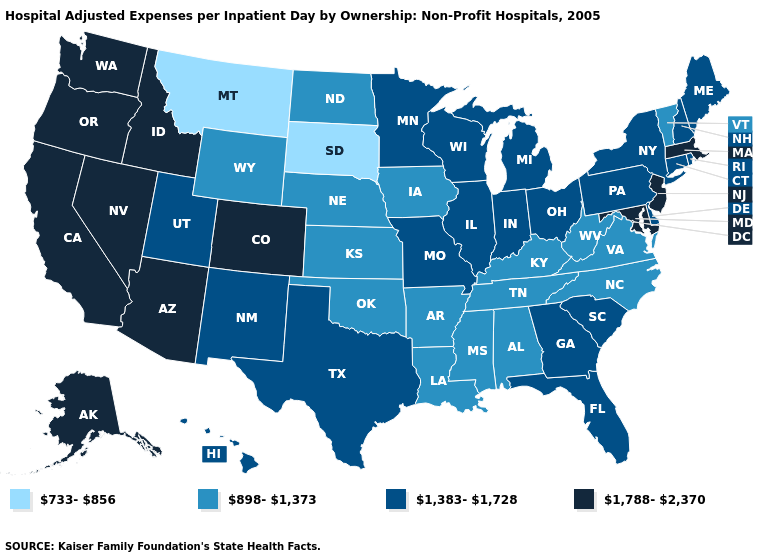What is the value of New Mexico?
Give a very brief answer. 1,383-1,728. What is the lowest value in states that border New Hampshire?
Keep it brief. 898-1,373. What is the value of Maryland?
Quick response, please. 1,788-2,370. Name the states that have a value in the range 1,788-2,370?
Write a very short answer. Alaska, Arizona, California, Colorado, Idaho, Maryland, Massachusetts, Nevada, New Jersey, Oregon, Washington. Does Delaware have a lower value than Texas?
Answer briefly. No. Among the states that border Kansas , which have the lowest value?
Concise answer only. Nebraska, Oklahoma. What is the lowest value in states that border Vermont?
Short answer required. 1,383-1,728. Among the states that border New Mexico , does Colorado have the highest value?
Write a very short answer. Yes. Name the states that have a value in the range 733-856?
Be succinct. Montana, South Dakota. Does Rhode Island have the same value as Illinois?
Keep it brief. Yes. What is the value of Idaho?
Keep it brief. 1,788-2,370. What is the lowest value in the MidWest?
Concise answer only. 733-856. Name the states that have a value in the range 733-856?
Be succinct. Montana, South Dakota. Name the states that have a value in the range 1,383-1,728?
Answer briefly. Connecticut, Delaware, Florida, Georgia, Hawaii, Illinois, Indiana, Maine, Michigan, Minnesota, Missouri, New Hampshire, New Mexico, New York, Ohio, Pennsylvania, Rhode Island, South Carolina, Texas, Utah, Wisconsin. Does North Dakota have the highest value in the USA?
Short answer required. No. 